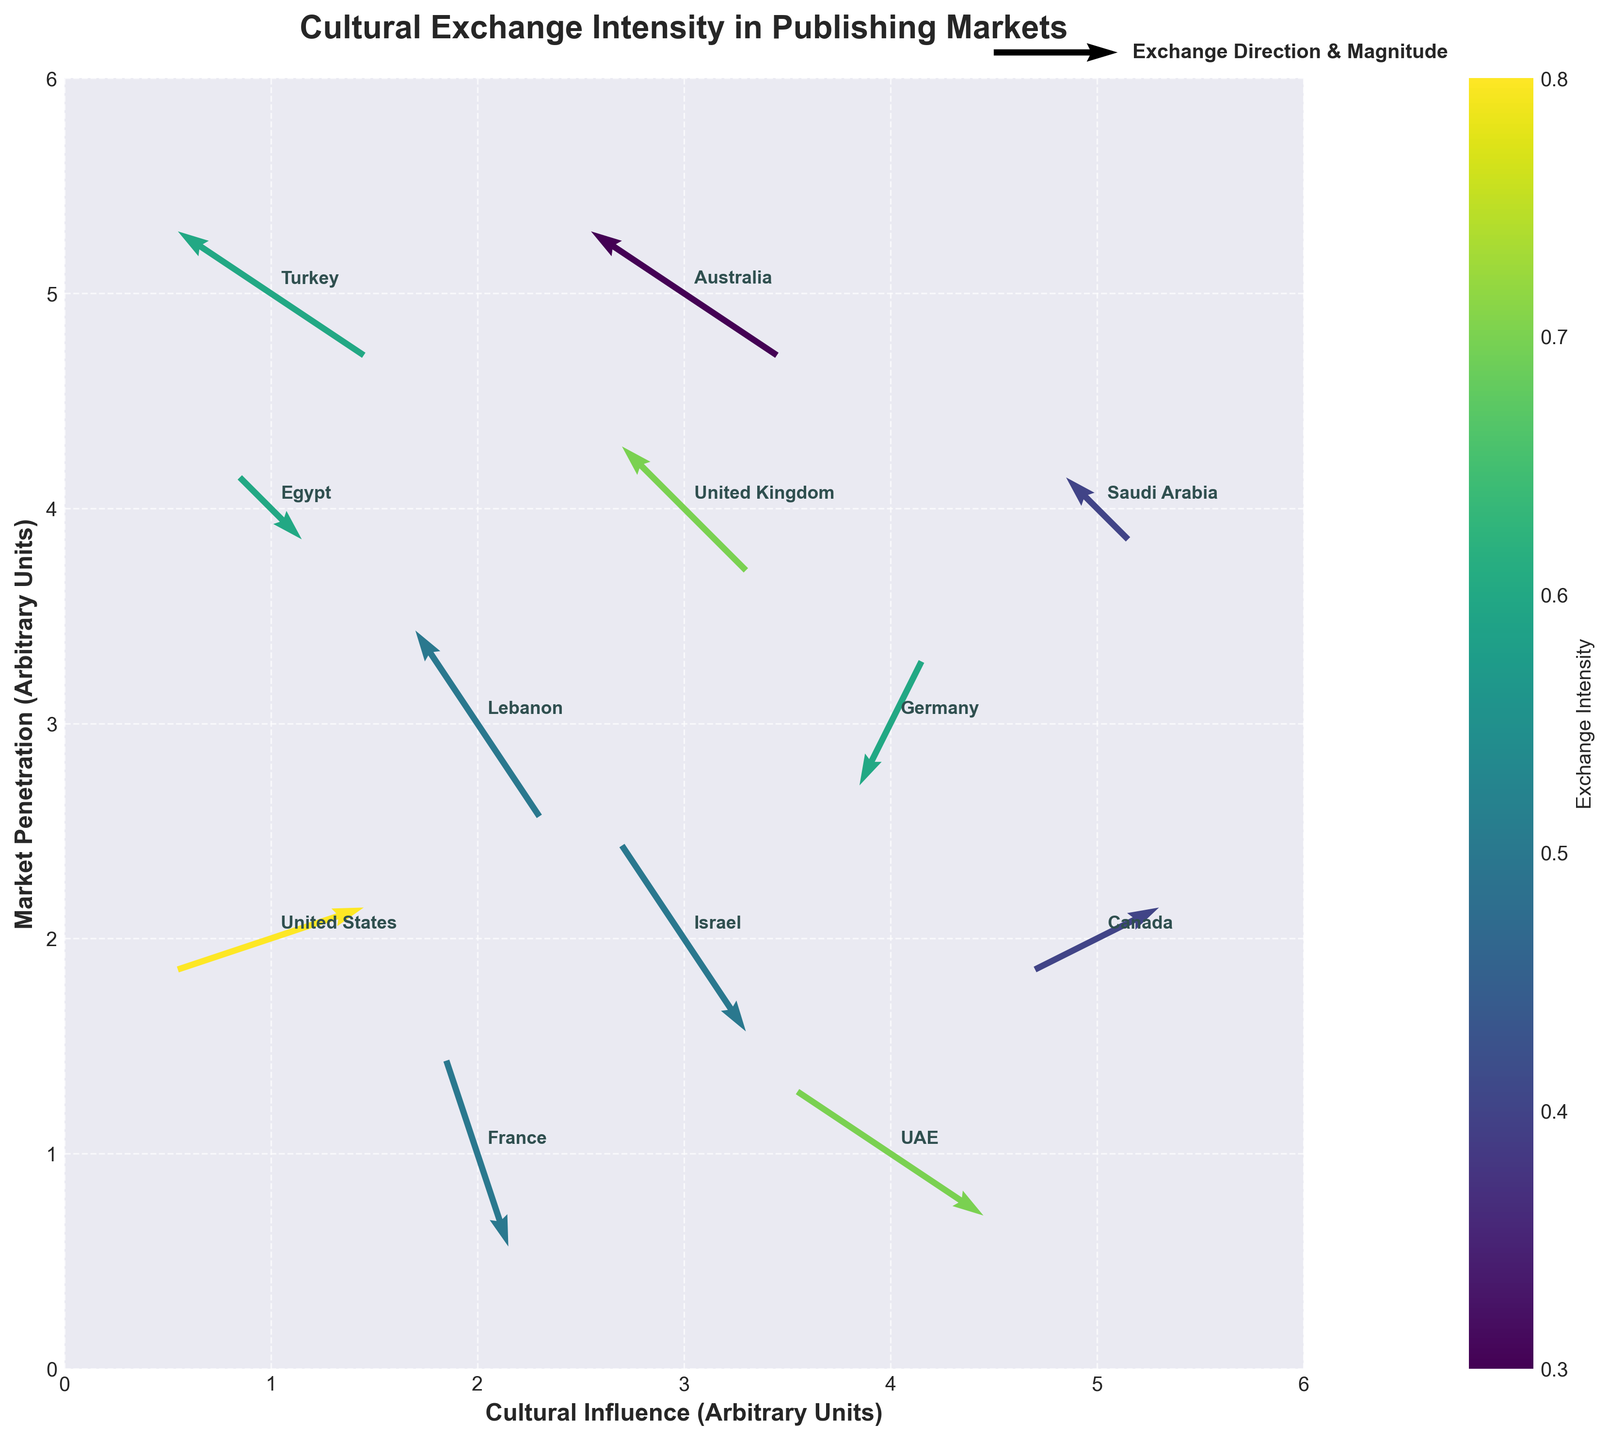What is the title of the figure? The title of the figure is located at the top center of the plot. Read the text to identify the title.
Answer: Cultural Exchange Intensity in Publishing Markets Which country has the highest exchange intensity? Look at the color scale to identify the intensity values. Find the arrow color closest to the maximum value on the color bar. Identify the country labeled at that point.
Answer: United States What is the direction of cultural exchange for Lebanon? Locate Lebanon on the plot by finding its label. Observe the direction of the arrow originating from that point.
Answer: The arrow points to the left and upwards Which country has the most negative horizontal component (U) of cultural exchange? Identify arrows pointing to the left (negative U). Compare their lengths. The longest left-pointing arrow indicates the most negative U component.
Answer: Australia How does the cultural exchange vector of the UAE compare to that of Germany? Identify both countries on the plot. Observe the direction and length of their arrows. The UAE's arrow points right and down, while Germany's points left and down.
Answer: UAE's vector points right and down, Germany's left and down How many countries have exchange intensity of 0.6? Refer to the color scale to see the color corresponding to 0.6. Count the number of arrows in that color.
Answer: Four countries What is the sum of the exchange intensities for countries with negative vertical components (V)? Identify countries with arrows pointing down (negative V). Add their exchange intensities: France (0.5), Germany (0.6), UAE (0.7), Israel (0.5). Sum these values.
Answer: 2.3 What is the average cultural influence (X-axis value) of countries from the Middle East? Identify Middle Eastern countries (Egypt, Lebanon, UAE, Saudi Arabia, Israel, Turkey). Sum their X-axis values and divide by the number of countries: (1+2+4+5+3+1)/6=16/6.
Answer: 2.67 